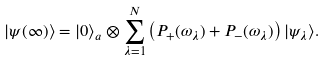Convert formula to latex. <formula><loc_0><loc_0><loc_500><loc_500>| \psi ( \infty ) \rangle = | 0 \rangle _ { a } \otimes \sum _ { \lambda = 1 } ^ { N } \left ( P _ { + } ( \omega _ { \lambda } ) + P _ { - } ( \omega _ { \lambda } ) \right ) | \psi _ { \lambda } \rangle .</formula> 